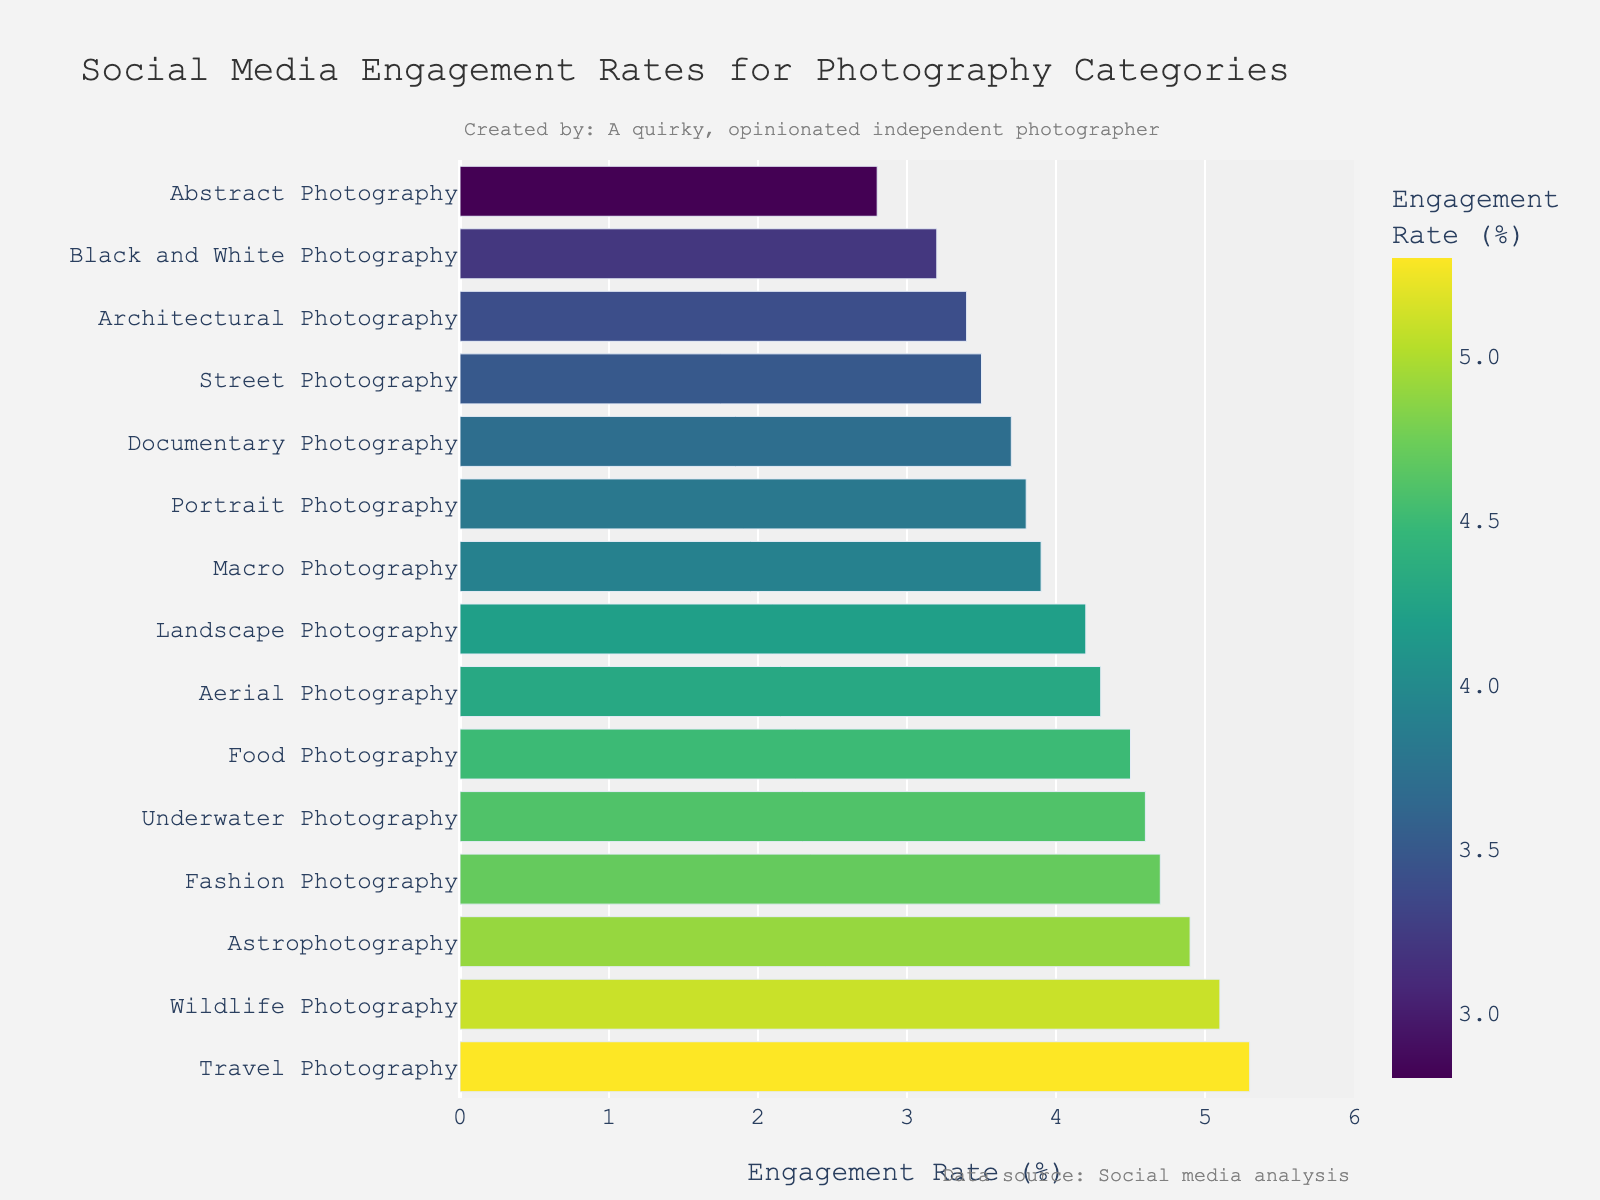What's the category with the highest engagement rate? The bar chart shows that Travel Photography has the highest engagement rate. By visually inspecting the length of the bars, Travel Photography is at the top with an engagement rate of 5.3%.
Answer: Travel Photography Which two categories have the lowest engagement rates? The two shortest bars represent Abstract Photography and Black and White Photography, which have engagement rates of 2.8% and 3.2% respectively.
Answer: Abstract Photography and Black and White Photography How much higher is the engagement rate of Wildlife Photography compared to Street Photography? Wildlife Photography has an engagement rate of 5.1%, whereas Street Photography has an engagement rate of 3.5%. The difference is calculated by subtracting 3.5% from 5.1%, resulting in 1.6%.
Answer: 1.6% What's the average engagement rate for Landscape Photography, Portrait Photography, and Street Photography? The engagement rates for Landscape, Portrait, and Street Photography are 4.2%, 3.8%, and 3.5% respectively. The average is calculated by summing these rates and dividing by 3: (4.2 + 3.8 + 3.5) / 3 = 3.833%.
Answer: 3.833% Which photography category is more engaging, Astrophotography or Aerial Photography, and by how much? Astrophotography has an engagement rate of 4.9%, while Aerial Photography has an engagement rate of 4.3%. The difference is calculated by subtracting 4.3% from 4.9%, resulting in 0.6%.
Answer: Astrophotography by 0.6% What’s the difference in engagement rate between the category with the highest rate and the category with the lowest rate? The highest engagement rate is for Travel Photography at 5.3%, and the lowest is for Abstract Photography at 2.8%. The difference is calculated by subtracting 2.8% from 5.3%, resulting in 2.5%.
Answer: 2.5% Which categories have an engagement rate above 4%? By visually inspecting the lengths of the bars, the categories with engagement rates above 4% are Landscape Photography (4.2%), Fashion Photography (4.7%), Food Photography (4.5%), Travel Photography (5.3%), Astrophotography (4.9%), Underwater Photography (4.6%), Aerial Photography (4.3%), and Wildlife Photography (5.1%).
Answer: Landscape, Fashion, Food, Travel, Astrophotography, Underwater, Aerial, and Wildlife Photography 